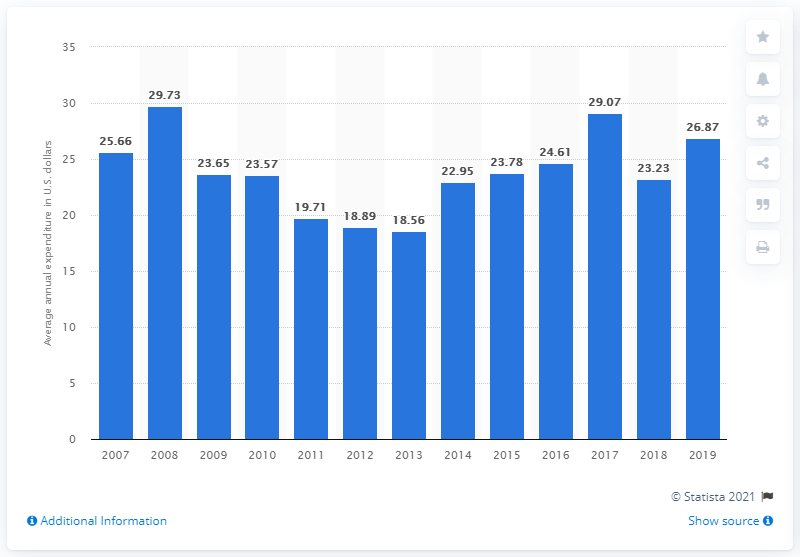Give some essential details in this illustration. In 2019, the average expenditure on tableware and non-electric kitchenware per consumer unit was 26.87. 